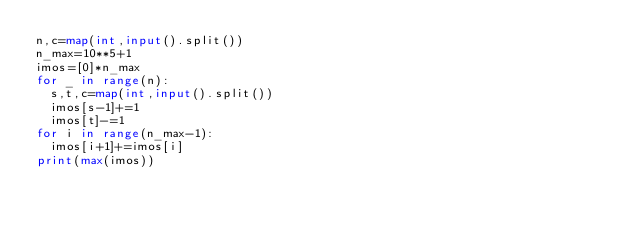Convert code to text. <code><loc_0><loc_0><loc_500><loc_500><_Python_>n,c=map(int,input().split())
n_max=10**5+1
imos=[0]*n_max
for _ in range(n):
  s,t,c=map(int,input().split())
  imos[s-1]+=1
  imos[t]-=1
for i in range(n_max-1):
  imos[i+1]+=imos[i]
print(max(imos))</code> 